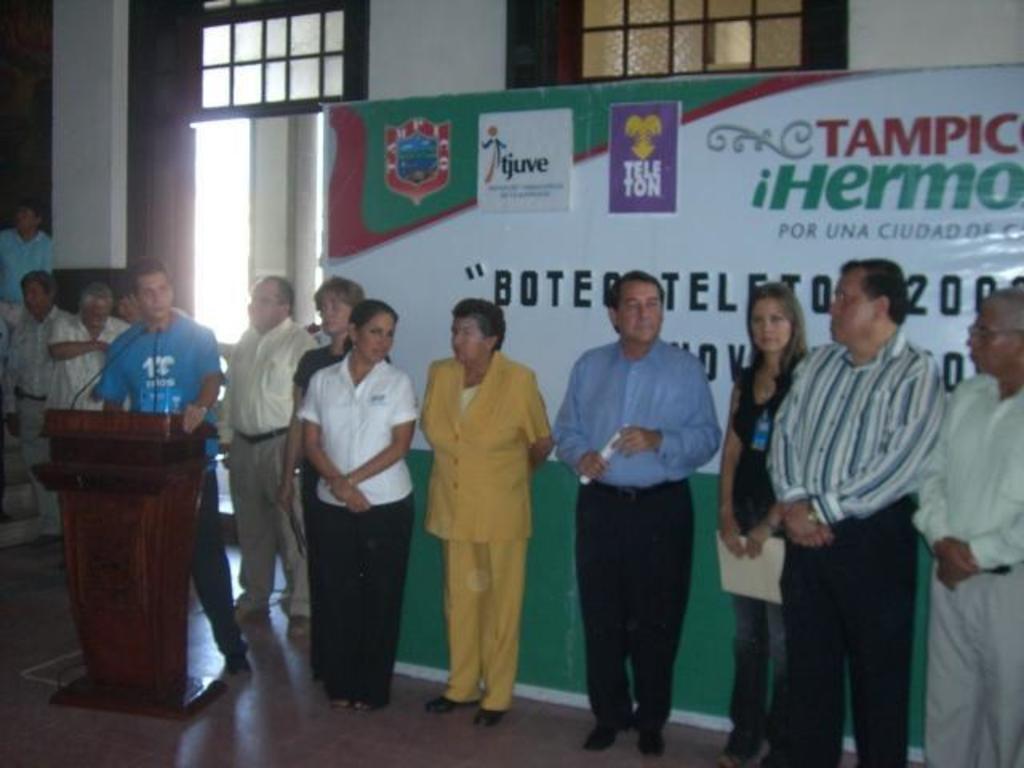Please provide a concise description of this image. In this image there are people standing. To the left there is a man standing at the podium. There are microphones on the podium. Behind the people there is a board. There are logos and text on the board. In the background there is a wall. There are ventilators to the wall. 